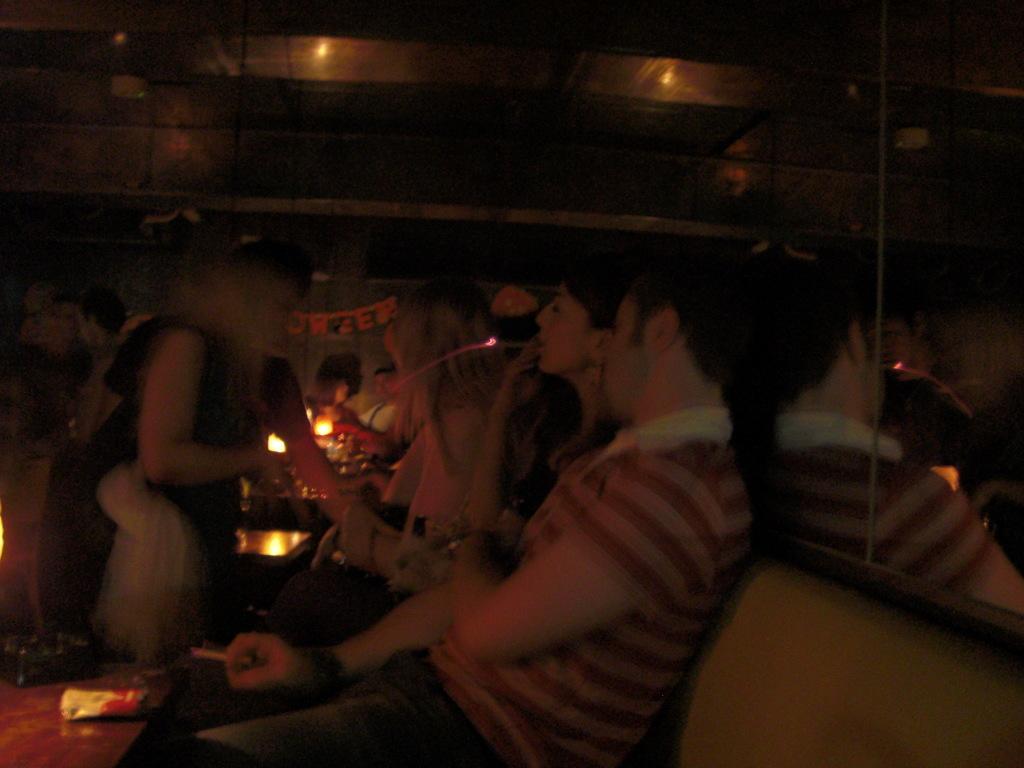How would you summarize this image in a sentence or two? In this image, we can see people sitting on the sofa and some are smoking and some are holding objects and we can see some lights, a mirror and there are some objects on the table. 